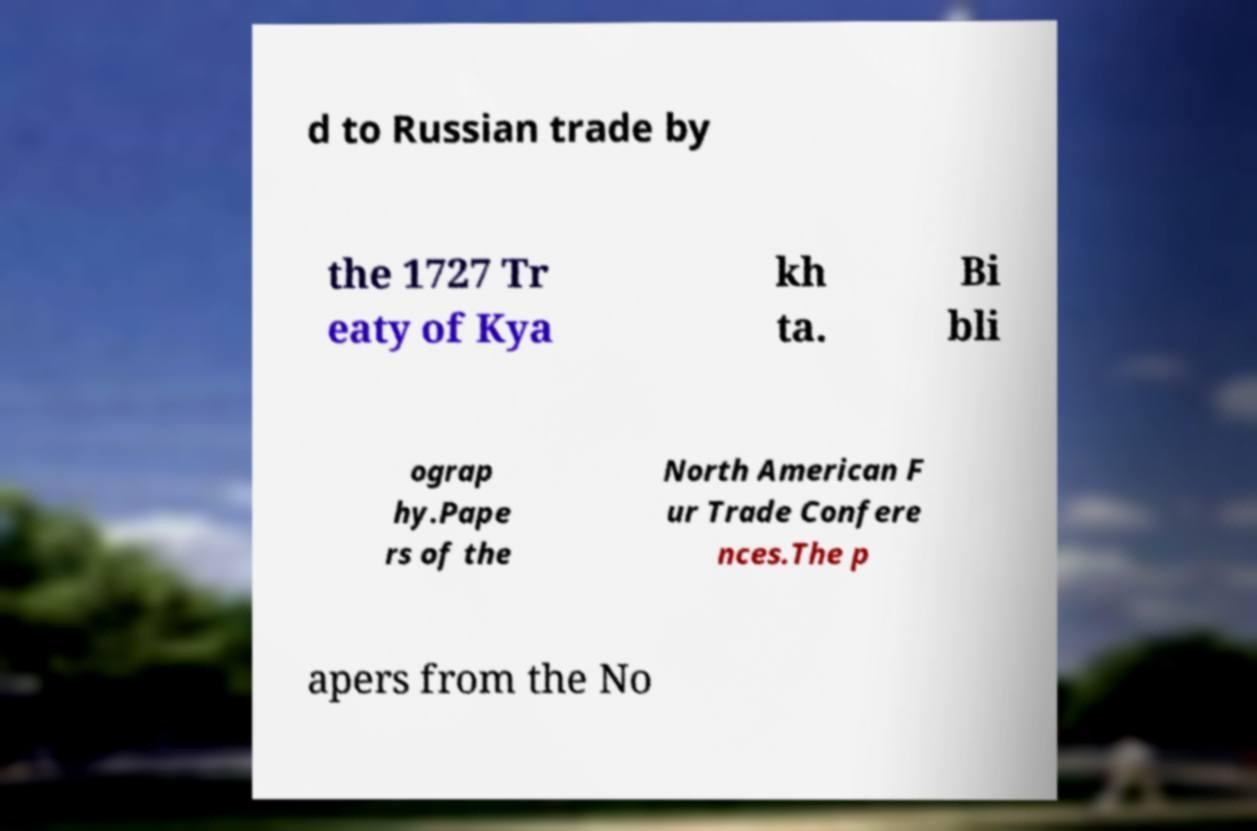Could you assist in decoding the text presented in this image and type it out clearly? d to Russian trade by the 1727 Tr eaty of Kya kh ta. Bi bli ograp hy.Pape rs of the North American F ur Trade Confere nces.The p apers from the No 